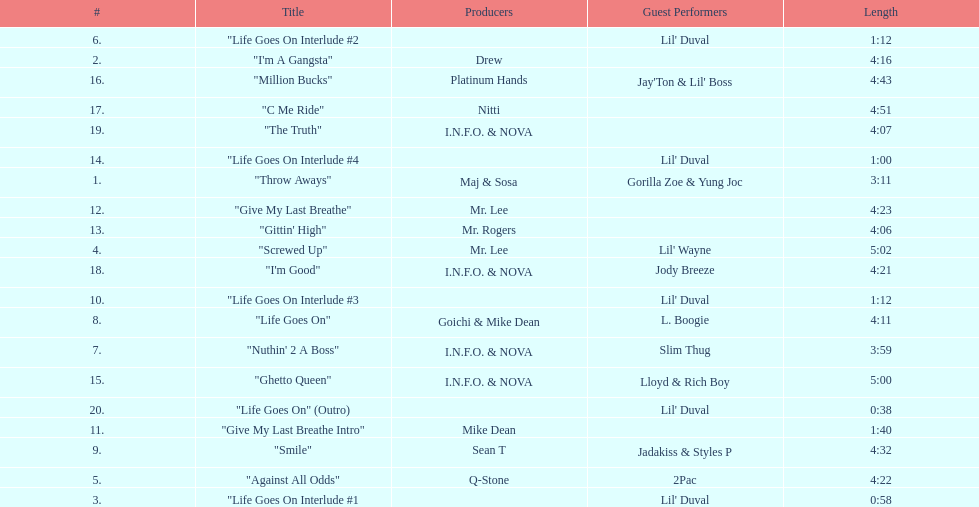What is the total number of tracks on the album? 20. 